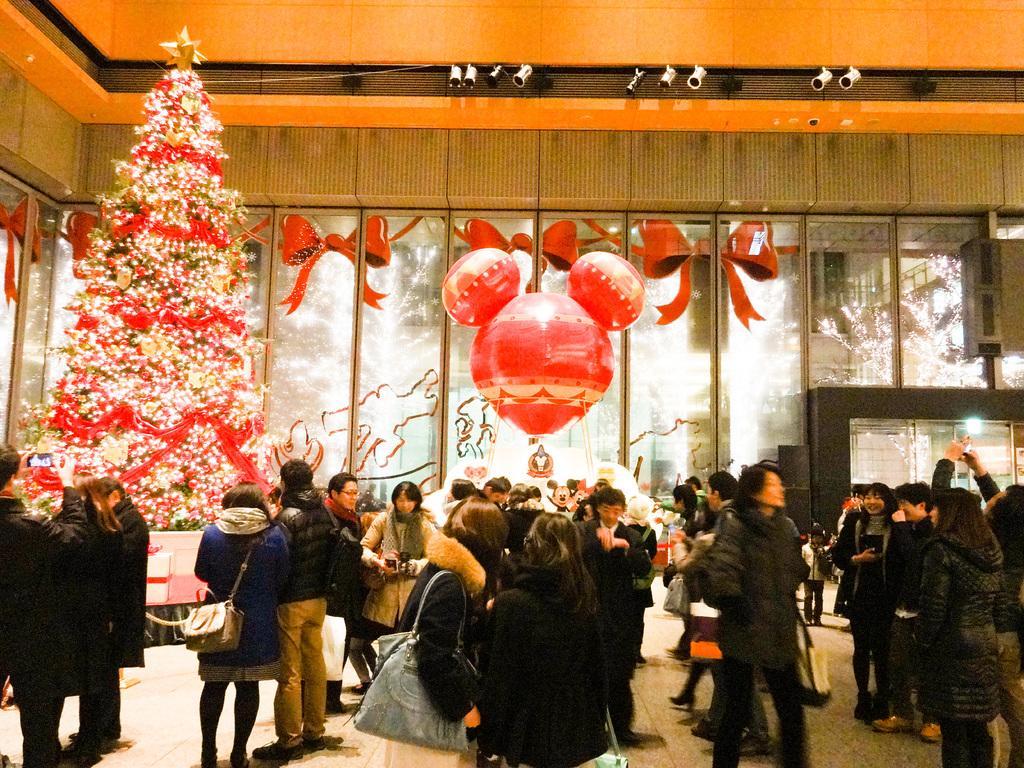Describe this image in one or two sentences. On the bottom we can see two women standing on the floor. Here we can see group of persons standing near to the christmas tree. Here we can see balloons. On the top we can see many cctv cameras. Through the window we can see trees. On the right there is a man who is holding mobile phone. 